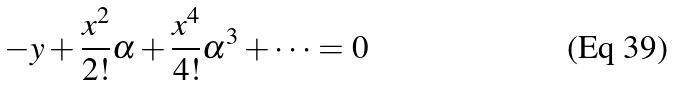Convert formula to latex. <formula><loc_0><loc_0><loc_500><loc_500>- y + \frac { x ^ { 2 } } { 2 ! } \alpha + \frac { x ^ { 4 } } { 4 ! } \alpha ^ { 3 } + \cdot \cdot \cdot = 0</formula> 